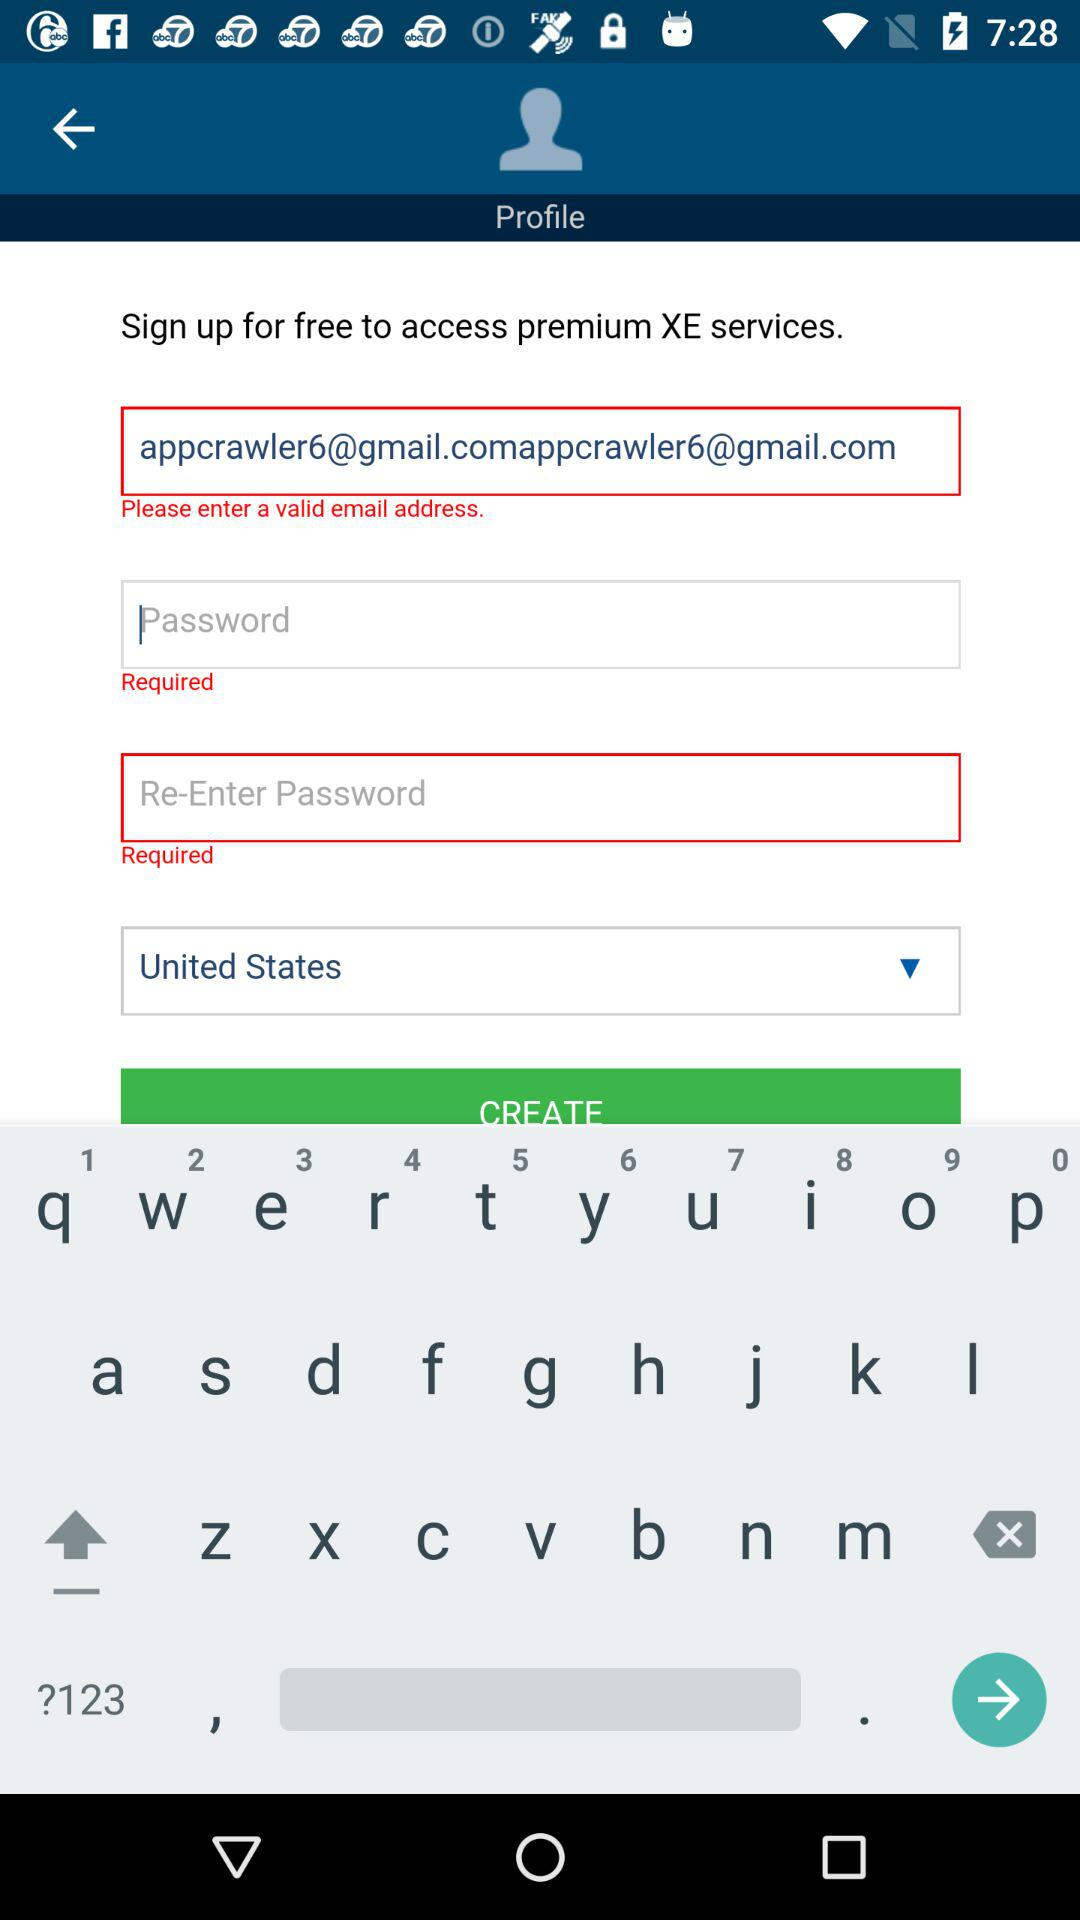What is the email address? The email address is appcrawler6@gmail.com. 